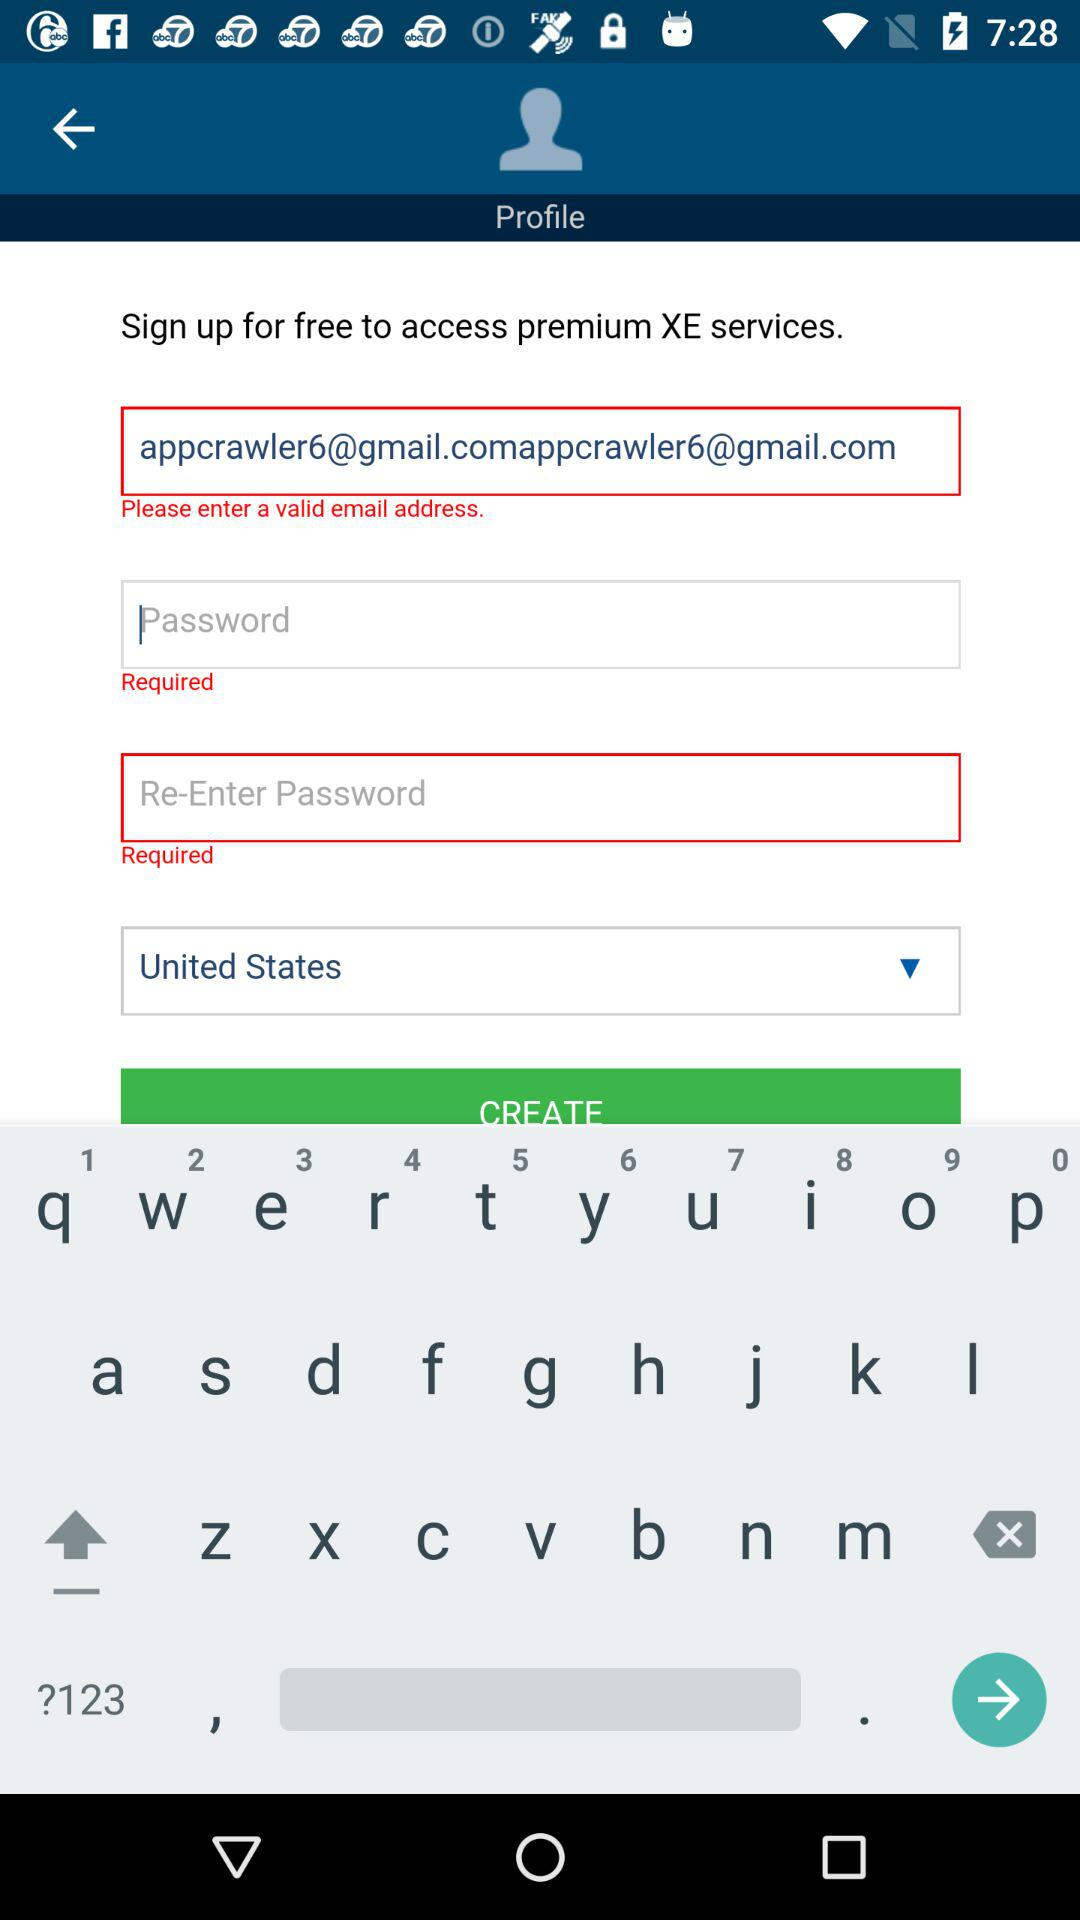What is the email address? The email address is appcrawler6@gmail.com. 